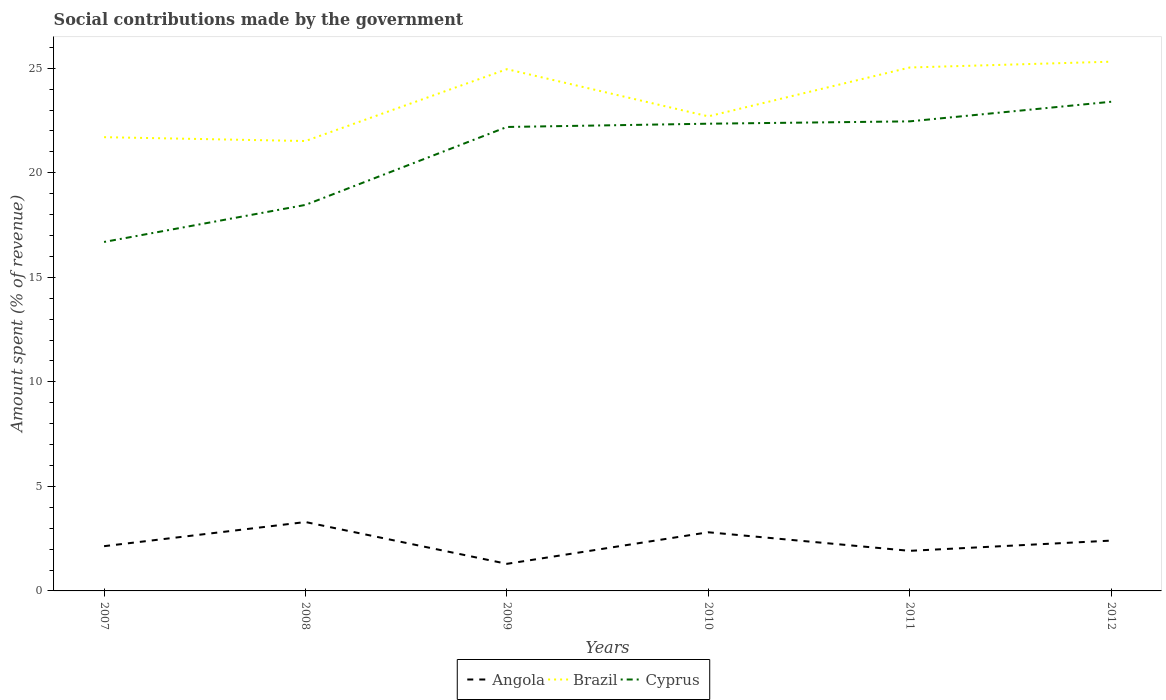Does the line corresponding to Brazil intersect with the line corresponding to Angola?
Make the answer very short. No. Is the number of lines equal to the number of legend labels?
Provide a short and direct response. Yes. Across all years, what is the maximum amount spent (in %) on social contributions in Brazil?
Provide a succinct answer. 21.52. What is the total amount spent (in %) on social contributions in Cyprus in the graph?
Offer a terse response. -0.27. What is the difference between the highest and the second highest amount spent (in %) on social contributions in Brazil?
Keep it short and to the point. 3.79. How many lines are there?
Provide a short and direct response. 3. Are the values on the major ticks of Y-axis written in scientific E-notation?
Provide a succinct answer. No. Does the graph contain any zero values?
Keep it short and to the point. No. Does the graph contain grids?
Provide a succinct answer. No. Where does the legend appear in the graph?
Your answer should be very brief. Bottom center. What is the title of the graph?
Offer a terse response. Social contributions made by the government. What is the label or title of the X-axis?
Provide a succinct answer. Years. What is the label or title of the Y-axis?
Make the answer very short. Amount spent (% of revenue). What is the Amount spent (% of revenue) of Angola in 2007?
Provide a succinct answer. 2.14. What is the Amount spent (% of revenue) in Brazil in 2007?
Keep it short and to the point. 21.7. What is the Amount spent (% of revenue) in Cyprus in 2007?
Ensure brevity in your answer.  16.69. What is the Amount spent (% of revenue) in Angola in 2008?
Make the answer very short. 3.29. What is the Amount spent (% of revenue) of Brazil in 2008?
Provide a short and direct response. 21.52. What is the Amount spent (% of revenue) in Cyprus in 2008?
Your answer should be compact. 18.46. What is the Amount spent (% of revenue) in Angola in 2009?
Your answer should be compact. 1.3. What is the Amount spent (% of revenue) in Brazil in 2009?
Your answer should be very brief. 24.95. What is the Amount spent (% of revenue) in Cyprus in 2009?
Ensure brevity in your answer.  22.19. What is the Amount spent (% of revenue) of Angola in 2010?
Provide a succinct answer. 2.81. What is the Amount spent (% of revenue) in Brazil in 2010?
Give a very brief answer. 22.7. What is the Amount spent (% of revenue) of Cyprus in 2010?
Give a very brief answer. 22.35. What is the Amount spent (% of revenue) in Angola in 2011?
Provide a succinct answer. 1.92. What is the Amount spent (% of revenue) of Brazil in 2011?
Ensure brevity in your answer.  25.03. What is the Amount spent (% of revenue) in Cyprus in 2011?
Offer a very short reply. 22.46. What is the Amount spent (% of revenue) in Angola in 2012?
Your answer should be compact. 2.41. What is the Amount spent (% of revenue) in Brazil in 2012?
Your response must be concise. 25.31. What is the Amount spent (% of revenue) in Cyprus in 2012?
Your answer should be compact. 23.4. Across all years, what is the maximum Amount spent (% of revenue) in Angola?
Provide a short and direct response. 3.29. Across all years, what is the maximum Amount spent (% of revenue) in Brazil?
Provide a short and direct response. 25.31. Across all years, what is the maximum Amount spent (% of revenue) in Cyprus?
Keep it short and to the point. 23.4. Across all years, what is the minimum Amount spent (% of revenue) of Angola?
Offer a very short reply. 1.3. Across all years, what is the minimum Amount spent (% of revenue) of Brazil?
Give a very brief answer. 21.52. Across all years, what is the minimum Amount spent (% of revenue) in Cyprus?
Your answer should be compact. 16.69. What is the total Amount spent (% of revenue) of Angola in the graph?
Make the answer very short. 13.86. What is the total Amount spent (% of revenue) of Brazil in the graph?
Offer a terse response. 141.22. What is the total Amount spent (% of revenue) of Cyprus in the graph?
Your answer should be very brief. 125.54. What is the difference between the Amount spent (% of revenue) in Angola in 2007 and that in 2008?
Your answer should be very brief. -1.16. What is the difference between the Amount spent (% of revenue) in Brazil in 2007 and that in 2008?
Your answer should be compact. 0.18. What is the difference between the Amount spent (% of revenue) in Cyprus in 2007 and that in 2008?
Give a very brief answer. -1.77. What is the difference between the Amount spent (% of revenue) of Angola in 2007 and that in 2009?
Provide a short and direct response. 0.84. What is the difference between the Amount spent (% of revenue) of Brazil in 2007 and that in 2009?
Provide a succinct answer. -3.25. What is the difference between the Amount spent (% of revenue) of Cyprus in 2007 and that in 2009?
Keep it short and to the point. -5.5. What is the difference between the Amount spent (% of revenue) of Angola in 2007 and that in 2010?
Your response must be concise. -0.67. What is the difference between the Amount spent (% of revenue) in Brazil in 2007 and that in 2010?
Give a very brief answer. -1. What is the difference between the Amount spent (% of revenue) in Cyprus in 2007 and that in 2010?
Provide a short and direct response. -5.66. What is the difference between the Amount spent (% of revenue) of Angola in 2007 and that in 2011?
Offer a terse response. 0.22. What is the difference between the Amount spent (% of revenue) in Brazil in 2007 and that in 2011?
Give a very brief answer. -3.33. What is the difference between the Amount spent (% of revenue) of Cyprus in 2007 and that in 2011?
Give a very brief answer. -5.77. What is the difference between the Amount spent (% of revenue) in Angola in 2007 and that in 2012?
Offer a very short reply. -0.27. What is the difference between the Amount spent (% of revenue) in Brazil in 2007 and that in 2012?
Your response must be concise. -3.61. What is the difference between the Amount spent (% of revenue) of Cyprus in 2007 and that in 2012?
Your answer should be very brief. -6.71. What is the difference between the Amount spent (% of revenue) in Angola in 2008 and that in 2009?
Make the answer very short. 2. What is the difference between the Amount spent (% of revenue) of Brazil in 2008 and that in 2009?
Ensure brevity in your answer.  -3.44. What is the difference between the Amount spent (% of revenue) of Cyprus in 2008 and that in 2009?
Your response must be concise. -3.73. What is the difference between the Amount spent (% of revenue) of Angola in 2008 and that in 2010?
Offer a very short reply. 0.49. What is the difference between the Amount spent (% of revenue) in Brazil in 2008 and that in 2010?
Your response must be concise. -1.18. What is the difference between the Amount spent (% of revenue) in Cyprus in 2008 and that in 2010?
Your answer should be compact. -3.88. What is the difference between the Amount spent (% of revenue) in Angola in 2008 and that in 2011?
Your response must be concise. 1.38. What is the difference between the Amount spent (% of revenue) of Brazil in 2008 and that in 2011?
Keep it short and to the point. -3.52. What is the difference between the Amount spent (% of revenue) of Cyprus in 2008 and that in 2011?
Offer a terse response. -4. What is the difference between the Amount spent (% of revenue) in Angola in 2008 and that in 2012?
Your answer should be compact. 0.89. What is the difference between the Amount spent (% of revenue) of Brazil in 2008 and that in 2012?
Your response must be concise. -3.79. What is the difference between the Amount spent (% of revenue) of Cyprus in 2008 and that in 2012?
Your answer should be very brief. -4.93. What is the difference between the Amount spent (% of revenue) in Angola in 2009 and that in 2010?
Keep it short and to the point. -1.51. What is the difference between the Amount spent (% of revenue) in Brazil in 2009 and that in 2010?
Provide a short and direct response. 2.26. What is the difference between the Amount spent (% of revenue) of Cyprus in 2009 and that in 2010?
Your answer should be compact. -0.16. What is the difference between the Amount spent (% of revenue) of Angola in 2009 and that in 2011?
Your answer should be compact. -0.62. What is the difference between the Amount spent (% of revenue) in Brazil in 2009 and that in 2011?
Make the answer very short. -0.08. What is the difference between the Amount spent (% of revenue) in Cyprus in 2009 and that in 2011?
Give a very brief answer. -0.27. What is the difference between the Amount spent (% of revenue) in Angola in 2009 and that in 2012?
Give a very brief answer. -1.11. What is the difference between the Amount spent (% of revenue) in Brazil in 2009 and that in 2012?
Keep it short and to the point. -0.36. What is the difference between the Amount spent (% of revenue) in Cyprus in 2009 and that in 2012?
Make the answer very short. -1.21. What is the difference between the Amount spent (% of revenue) in Angola in 2010 and that in 2011?
Provide a short and direct response. 0.89. What is the difference between the Amount spent (% of revenue) of Brazil in 2010 and that in 2011?
Keep it short and to the point. -2.34. What is the difference between the Amount spent (% of revenue) of Cyprus in 2010 and that in 2011?
Make the answer very short. -0.11. What is the difference between the Amount spent (% of revenue) of Angola in 2010 and that in 2012?
Provide a succinct answer. 0.4. What is the difference between the Amount spent (% of revenue) of Brazil in 2010 and that in 2012?
Provide a succinct answer. -2.62. What is the difference between the Amount spent (% of revenue) of Cyprus in 2010 and that in 2012?
Your answer should be very brief. -1.05. What is the difference between the Amount spent (% of revenue) in Angola in 2011 and that in 2012?
Ensure brevity in your answer.  -0.49. What is the difference between the Amount spent (% of revenue) of Brazil in 2011 and that in 2012?
Your answer should be very brief. -0.28. What is the difference between the Amount spent (% of revenue) in Cyprus in 2011 and that in 2012?
Offer a very short reply. -0.94. What is the difference between the Amount spent (% of revenue) of Angola in 2007 and the Amount spent (% of revenue) of Brazil in 2008?
Make the answer very short. -19.38. What is the difference between the Amount spent (% of revenue) in Angola in 2007 and the Amount spent (% of revenue) in Cyprus in 2008?
Keep it short and to the point. -16.32. What is the difference between the Amount spent (% of revenue) in Brazil in 2007 and the Amount spent (% of revenue) in Cyprus in 2008?
Your answer should be compact. 3.24. What is the difference between the Amount spent (% of revenue) in Angola in 2007 and the Amount spent (% of revenue) in Brazil in 2009?
Ensure brevity in your answer.  -22.81. What is the difference between the Amount spent (% of revenue) of Angola in 2007 and the Amount spent (% of revenue) of Cyprus in 2009?
Your answer should be very brief. -20.05. What is the difference between the Amount spent (% of revenue) in Brazil in 2007 and the Amount spent (% of revenue) in Cyprus in 2009?
Your response must be concise. -0.49. What is the difference between the Amount spent (% of revenue) in Angola in 2007 and the Amount spent (% of revenue) in Brazil in 2010?
Your answer should be compact. -20.56. What is the difference between the Amount spent (% of revenue) in Angola in 2007 and the Amount spent (% of revenue) in Cyprus in 2010?
Your answer should be compact. -20.21. What is the difference between the Amount spent (% of revenue) in Brazil in 2007 and the Amount spent (% of revenue) in Cyprus in 2010?
Ensure brevity in your answer.  -0.64. What is the difference between the Amount spent (% of revenue) in Angola in 2007 and the Amount spent (% of revenue) in Brazil in 2011?
Keep it short and to the point. -22.89. What is the difference between the Amount spent (% of revenue) in Angola in 2007 and the Amount spent (% of revenue) in Cyprus in 2011?
Your response must be concise. -20.32. What is the difference between the Amount spent (% of revenue) of Brazil in 2007 and the Amount spent (% of revenue) of Cyprus in 2011?
Keep it short and to the point. -0.76. What is the difference between the Amount spent (% of revenue) in Angola in 2007 and the Amount spent (% of revenue) in Brazil in 2012?
Give a very brief answer. -23.17. What is the difference between the Amount spent (% of revenue) of Angola in 2007 and the Amount spent (% of revenue) of Cyprus in 2012?
Your answer should be compact. -21.26. What is the difference between the Amount spent (% of revenue) in Brazil in 2007 and the Amount spent (% of revenue) in Cyprus in 2012?
Give a very brief answer. -1.69. What is the difference between the Amount spent (% of revenue) of Angola in 2008 and the Amount spent (% of revenue) of Brazil in 2009?
Provide a short and direct response. -21.66. What is the difference between the Amount spent (% of revenue) of Angola in 2008 and the Amount spent (% of revenue) of Cyprus in 2009?
Your answer should be very brief. -18.89. What is the difference between the Amount spent (% of revenue) in Brazil in 2008 and the Amount spent (% of revenue) in Cyprus in 2009?
Keep it short and to the point. -0.67. What is the difference between the Amount spent (% of revenue) of Angola in 2008 and the Amount spent (% of revenue) of Brazil in 2010?
Give a very brief answer. -19.4. What is the difference between the Amount spent (% of revenue) in Angola in 2008 and the Amount spent (% of revenue) in Cyprus in 2010?
Provide a short and direct response. -19.05. What is the difference between the Amount spent (% of revenue) in Brazil in 2008 and the Amount spent (% of revenue) in Cyprus in 2010?
Your answer should be compact. -0.83. What is the difference between the Amount spent (% of revenue) in Angola in 2008 and the Amount spent (% of revenue) in Brazil in 2011?
Make the answer very short. -21.74. What is the difference between the Amount spent (% of revenue) of Angola in 2008 and the Amount spent (% of revenue) of Cyprus in 2011?
Make the answer very short. -19.16. What is the difference between the Amount spent (% of revenue) of Brazil in 2008 and the Amount spent (% of revenue) of Cyprus in 2011?
Offer a very short reply. -0.94. What is the difference between the Amount spent (% of revenue) in Angola in 2008 and the Amount spent (% of revenue) in Brazil in 2012?
Make the answer very short. -22.02. What is the difference between the Amount spent (% of revenue) in Angola in 2008 and the Amount spent (% of revenue) in Cyprus in 2012?
Give a very brief answer. -20.1. What is the difference between the Amount spent (% of revenue) in Brazil in 2008 and the Amount spent (% of revenue) in Cyprus in 2012?
Provide a succinct answer. -1.88. What is the difference between the Amount spent (% of revenue) in Angola in 2009 and the Amount spent (% of revenue) in Brazil in 2010?
Keep it short and to the point. -21.4. What is the difference between the Amount spent (% of revenue) in Angola in 2009 and the Amount spent (% of revenue) in Cyprus in 2010?
Make the answer very short. -21.05. What is the difference between the Amount spent (% of revenue) in Brazil in 2009 and the Amount spent (% of revenue) in Cyprus in 2010?
Provide a succinct answer. 2.61. What is the difference between the Amount spent (% of revenue) of Angola in 2009 and the Amount spent (% of revenue) of Brazil in 2011?
Provide a succinct answer. -23.74. What is the difference between the Amount spent (% of revenue) in Angola in 2009 and the Amount spent (% of revenue) in Cyprus in 2011?
Provide a short and direct response. -21.16. What is the difference between the Amount spent (% of revenue) in Brazil in 2009 and the Amount spent (% of revenue) in Cyprus in 2011?
Provide a succinct answer. 2.5. What is the difference between the Amount spent (% of revenue) of Angola in 2009 and the Amount spent (% of revenue) of Brazil in 2012?
Make the answer very short. -24.02. What is the difference between the Amount spent (% of revenue) in Angola in 2009 and the Amount spent (% of revenue) in Cyprus in 2012?
Provide a succinct answer. -22.1. What is the difference between the Amount spent (% of revenue) in Brazil in 2009 and the Amount spent (% of revenue) in Cyprus in 2012?
Provide a short and direct response. 1.56. What is the difference between the Amount spent (% of revenue) in Angola in 2010 and the Amount spent (% of revenue) in Brazil in 2011?
Make the answer very short. -22.23. What is the difference between the Amount spent (% of revenue) in Angola in 2010 and the Amount spent (% of revenue) in Cyprus in 2011?
Provide a short and direct response. -19.65. What is the difference between the Amount spent (% of revenue) in Brazil in 2010 and the Amount spent (% of revenue) in Cyprus in 2011?
Give a very brief answer. 0.24. What is the difference between the Amount spent (% of revenue) in Angola in 2010 and the Amount spent (% of revenue) in Brazil in 2012?
Provide a short and direct response. -22.51. What is the difference between the Amount spent (% of revenue) of Angola in 2010 and the Amount spent (% of revenue) of Cyprus in 2012?
Your response must be concise. -20.59. What is the difference between the Amount spent (% of revenue) in Brazil in 2010 and the Amount spent (% of revenue) in Cyprus in 2012?
Provide a short and direct response. -0.7. What is the difference between the Amount spent (% of revenue) of Angola in 2011 and the Amount spent (% of revenue) of Brazil in 2012?
Keep it short and to the point. -23.4. What is the difference between the Amount spent (% of revenue) in Angola in 2011 and the Amount spent (% of revenue) in Cyprus in 2012?
Give a very brief answer. -21.48. What is the difference between the Amount spent (% of revenue) in Brazil in 2011 and the Amount spent (% of revenue) in Cyprus in 2012?
Offer a terse response. 1.64. What is the average Amount spent (% of revenue) in Angola per year?
Your answer should be compact. 2.31. What is the average Amount spent (% of revenue) of Brazil per year?
Give a very brief answer. 23.54. What is the average Amount spent (% of revenue) of Cyprus per year?
Your answer should be very brief. 20.92. In the year 2007, what is the difference between the Amount spent (% of revenue) in Angola and Amount spent (% of revenue) in Brazil?
Give a very brief answer. -19.56. In the year 2007, what is the difference between the Amount spent (% of revenue) in Angola and Amount spent (% of revenue) in Cyprus?
Your answer should be compact. -14.55. In the year 2007, what is the difference between the Amount spent (% of revenue) in Brazil and Amount spent (% of revenue) in Cyprus?
Make the answer very short. 5.01. In the year 2008, what is the difference between the Amount spent (% of revenue) in Angola and Amount spent (% of revenue) in Brazil?
Offer a terse response. -18.22. In the year 2008, what is the difference between the Amount spent (% of revenue) of Angola and Amount spent (% of revenue) of Cyprus?
Keep it short and to the point. -15.17. In the year 2008, what is the difference between the Amount spent (% of revenue) of Brazil and Amount spent (% of revenue) of Cyprus?
Give a very brief answer. 3.06. In the year 2009, what is the difference between the Amount spent (% of revenue) of Angola and Amount spent (% of revenue) of Brazil?
Give a very brief answer. -23.66. In the year 2009, what is the difference between the Amount spent (% of revenue) of Angola and Amount spent (% of revenue) of Cyprus?
Your answer should be compact. -20.89. In the year 2009, what is the difference between the Amount spent (% of revenue) of Brazil and Amount spent (% of revenue) of Cyprus?
Offer a terse response. 2.76. In the year 2010, what is the difference between the Amount spent (% of revenue) in Angola and Amount spent (% of revenue) in Brazil?
Provide a short and direct response. -19.89. In the year 2010, what is the difference between the Amount spent (% of revenue) in Angola and Amount spent (% of revenue) in Cyprus?
Offer a very short reply. -19.54. In the year 2010, what is the difference between the Amount spent (% of revenue) in Brazil and Amount spent (% of revenue) in Cyprus?
Your answer should be compact. 0.35. In the year 2011, what is the difference between the Amount spent (% of revenue) in Angola and Amount spent (% of revenue) in Brazil?
Make the answer very short. -23.12. In the year 2011, what is the difference between the Amount spent (% of revenue) of Angola and Amount spent (% of revenue) of Cyprus?
Provide a short and direct response. -20.54. In the year 2011, what is the difference between the Amount spent (% of revenue) in Brazil and Amount spent (% of revenue) in Cyprus?
Offer a terse response. 2.58. In the year 2012, what is the difference between the Amount spent (% of revenue) in Angola and Amount spent (% of revenue) in Brazil?
Your answer should be very brief. -22.91. In the year 2012, what is the difference between the Amount spent (% of revenue) in Angola and Amount spent (% of revenue) in Cyprus?
Keep it short and to the point. -20.99. In the year 2012, what is the difference between the Amount spent (% of revenue) of Brazil and Amount spent (% of revenue) of Cyprus?
Offer a terse response. 1.92. What is the ratio of the Amount spent (% of revenue) of Angola in 2007 to that in 2008?
Your answer should be compact. 0.65. What is the ratio of the Amount spent (% of revenue) in Brazil in 2007 to that in 2008?
Your response must be concise. 1.01. What is the ratio of the Amount spent (% of revenue) of Cyprus in 2007 to that in 2008?
Offer a very short reply. 0.9. What is the ratio of the Amount spent (% of revenue) of Angola in 2007 to that in 2009?
Make the answer very short. 1.65. What is the ratio of the Amount spent (% of revenue) of Brazil in 2007 to that in 2009?
Give a very brief answer. 0.87. What is the ratio of the Amount spent (% of revenue) of Cyprus in 2007 to that in 2009?
Provide a short and direct response. 0.75. What is the ratio of the Amount spent (% of revenue) in Angola in 2007 to that in 2010?
Keep it short and to the point. 0.76. What is the ratio of the Amount spent (% of revenue) in Brazil in 2007 to that in 2010?
Your answer should be compact. 0.96. What is the ratio of the Amount spent (% of revenue) of Cyprus in 2007 to that in 2010?
Provide a succinct answer. 0.75. What is the ratio of the Amount spent (% of revenue) of Angola in 2007 to that in 2011?
Make the answer very short. 1.12. What is the ratio of the Amount spent (% of revenue) of Brazil in 2007 to that in 2011?
Your answer should be compact. 0.87. What is the ratio of the Amount spent (% of revenue) of Cyprus in 2007 to that in 2011?
Provide a succinct answer. 0.74. What is the ratio of the Amount spent (% of revenue) in Angola in 2007 to that in 2012?
Give a very brief answer. 0.89. What is the ratio of the Amount spent (% of revenue) in Brazil in 2007 to that in 2012?
Give a very brief answer. 0.86. What is the ratio of the Amount spent (% of revenue) in Cyprus in 2007 to that in 2012?
Ensure brevity in your answer.  0.71. What is the ratio of the Amount spent (% of revenue) in Angola in 2008 to that in 2009?
Provide a succinct answer. 2.54. What is the ratio of the Amount spent (% of revenue) of Brazil in 2008 to that in 2009?
Provide a succinct answer. 0.86. What is the ratio of the Amount spent (% of revenue) in Cyprus in 2008 to that in 2009?
Make the answer very short. 0.83. What is the ratio of the Amount spent (% of revenue) of Angola in 2008 to that in 2010?
Ensure brevity in your answer.  1.17. What is the ratio of the Amount spent (% of revenue) of Brazil in 2008 to that in 2010?
Provide a succinct answer. 0.95. What is the ratio of the Amount spent (% of revenue) of Cyprus in 2008 to that in 2010?
Provide a short and direct response. 0.83. What is the ratio of the Amount spent (% of revenue) in Angola in 2008 to that in 2011?
Give a very brief answer. 1.72. What is the ratio of the Amount spent (% of revenue) of Brazil in 2008 to that in 2011?
Make the answer very short. 0.86. What is the ratio of the Amount spent (% of revenue) of Cyprus in 2008 to that in 2011?
Offer a terse response. 0.82. What is the ratio of the Amount spent (% of revenue) of Angola in 2008 to that in 2012?
Offer a very short reply. 1.37. What is the ratio of the Amount spent (% of revenue) of Brazil in 2008 to that in 2012?
Your answer should be very brief. 0.85. What is the ratio of the Amount spent (% of revenue) of Cyprus in 2008 to that in 2012?
Your response must be concise. 0.79. What is the ratio of the Amount spent (% of revenue) of Angola in 2009 to that in 2010?
Ensure brevity in your answer.  0.46. What is the ratio of the Amount spent (% of revenue) in Brazil in 2009 to that in 2010?
Your answer should be compact. 1.1. What is the ratio of the Amount spent (% of revenue) in Cyprus in 2009 to that in 2010?
Make the answer very short. 0.99. What is the ratio of the Amount spent (% of revenue) in Angola in 2009 to that in 2011?
Your answer should be very brief. 0.68. What is the ratio of the Amount spent (% of revenue) in Brazil in 2009 to that in 2011?
Give a very brief answer. 1. What is the ratio of the Amount spent (% of revenue) in Cyprus in 2009 to that in 2011?
Offer a very short reply. 0.99. What is the ratio of the Amount spent (% of revenue) of Angola in 2009 to that in 2012?
Offer a very short reply. 0.54. What is the ratio of the Amount spent (% of revenue) of Brazil in 2009 to that in 2012?
Offer a very short reply. 0.99. What is the ratio of the Amount spent (% of revenue) of Cyprus in 2009 to that in 2012?
Offer a terse response. 0.95. What is the ratio of the Amount spent (% of revenue) in Angola in 2010 to that in 2011?
Ensure brevity in your answer.  1.46. What is the ratio of the Amount spent (% of revenue) of Brazil in 2010 to that in 2011?
Your answer should be very brief. 0.91. What is the ratio of the Amount spent (% of revenue) in Cyprus in 2010 to that in 2011?
Provide a succinct answer. 0.99. What is the ratio of the Amount spent (% of revenue) of Angola in 2010 to that in 2012?
Ensure brevity in your answer.  1.17. What is the ratio of the Amount spent (% of revenue) of Brazil in 2010 to that in 2012?
Your response must be concise. 0.9. What is the ratio of the Amount spent (% of revenue) in Cyprus in 2010 to that in 2012?
Offer a very short reply. 0.96. What is the ratio of the Amount spent (% of revenue) of Angola in 2011 to that in 2012?
Offer a very short reply. 0.8. What is the ratio of the Amount spent (% of revenue) in Brazil in 2011 to that in 2012?
Your response must be concise. 0.99. What is the ratio of the Amount spent (% of revenue) in Cyprus in 2011 to that in 2012?
Keep it short and to the point. 0.96. What is the difference between the highest and the second highest Amount spent (% of revenue) of Angola?
Give a very brief answer. 0.49. What is the difference between the highest and the second highest Amount spent (% of revenue) of Brazil?
Keep it short and to the point. 0.28. What is the difference between the highest and the second highest Amount spent (% of revenue) of Cyprus?
Provide a short and direct response. 0.94. What is the difference between the highest and the lowest Amount spent (% of revenue) in Angola?
Keep it short and to the point. 2. What is the difference between the highest and the lowest Amount spent (% of revenue) in Brazil?
Give a very brief answer. 3.79. What is the difference between the highest and the lowest Amount spent (% of revenue) in Cyprus?
Provide a succinct answer. 6.71. 